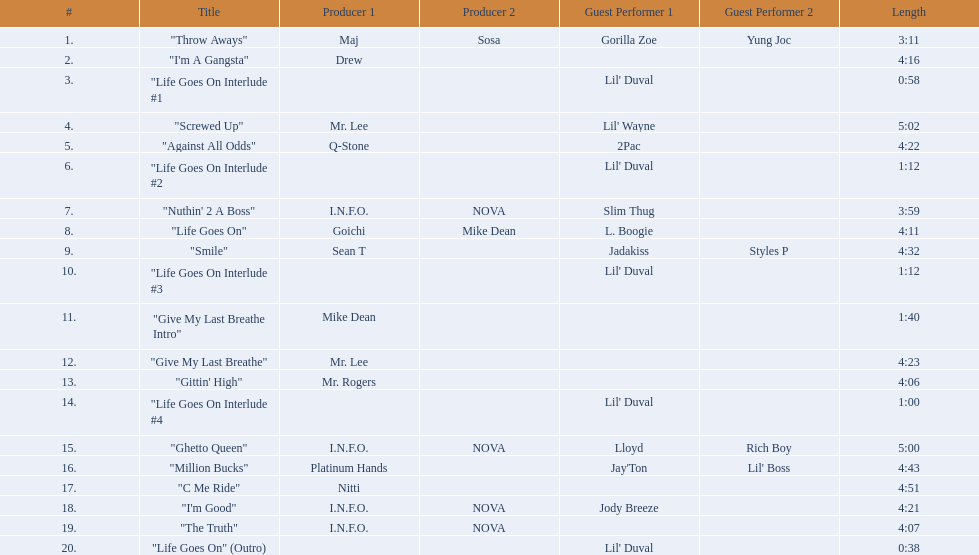What tracks appear on the album life goes on (trae album)? "Throw Aways", "I'm A Gangsta", "Life Goes On Interlude #1, "Screwed Up", "Against All Odds", "Life Goes On Interlude #2, "Nuthin' 2 A Boss", "Life Goes On", "Smile", "Life Goes On Interlude #3, "Give My Last Breathe Intro", "Give My Last Breathe", "Gittin' High", "Life Goes On Interlude #4, "Ghetto Queen", "Million Bucks", "C Me Ride", "I'm Good", "The Truth", "Life Goes On" (Outro). Which of these songs are at least 5 minutes long? "Screwed Up", "Ghetto Queen". Of these two songs over 5 minutes long, which is longer? "Screwed Up". How long is this track? 5:02. 